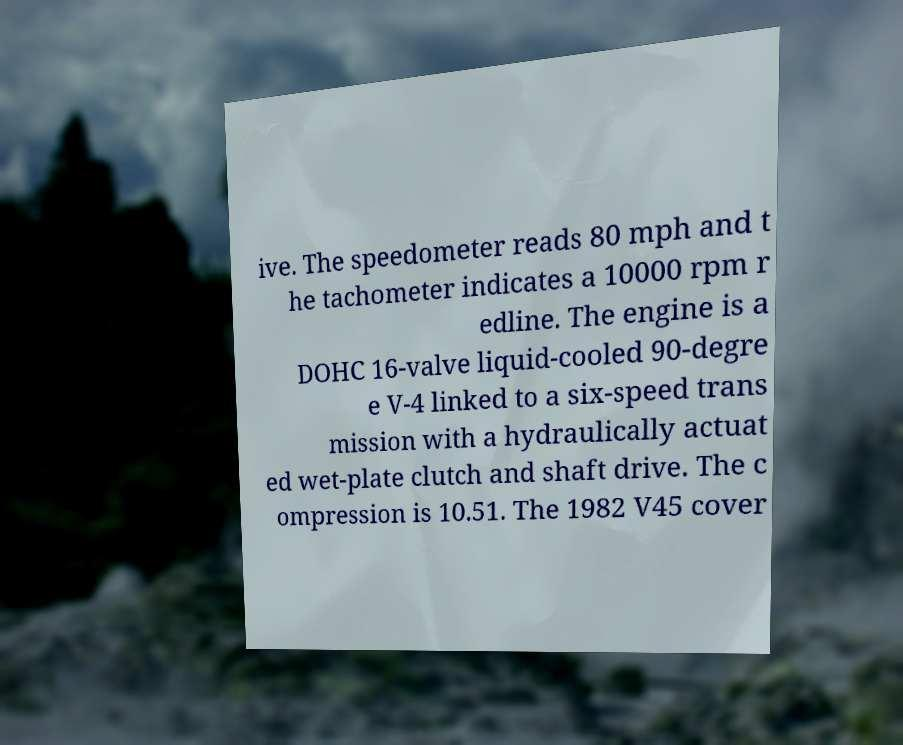Please read and relay the text visible in this image. What does it say? ive. The speedometer reads 80 mph and t he tachometer indicates a 10000 rpm r edline. The engine is a DOHC 16-valve liquid-cooled 90-degre e V-4 linked to a six-speed trans mission with a hydraulically actuat ed wet-plate clutch and shaft drive. The c ompression is 10.51. The 1982 V45 cover 